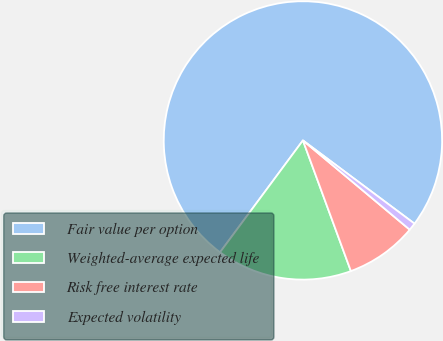<chart> <loc_0><loc_0><loc_500><loc_500><pie_chart><fcel>Fair value per option<fcel>Weighted-average expected life<fcel>Risk free interest rate<fcel>Expected volatility<nl><fcel>75.05%<fcel>15.75%<fcel>8.32%<fcel>0.88%<nl></chart> 